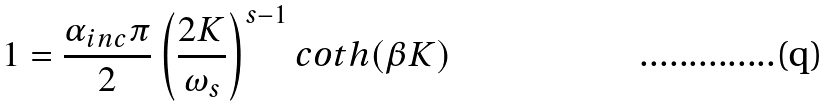<formula> <loc_0><loc_0><loc_500><loc_500>1 = \frac { \alpha _ { i n c } \pi } { 2 } \left ( \frac { 2 K } { \omega _ { s } } \right ) ^ { s - 1 } c o t h ( \beta K )</formula> 